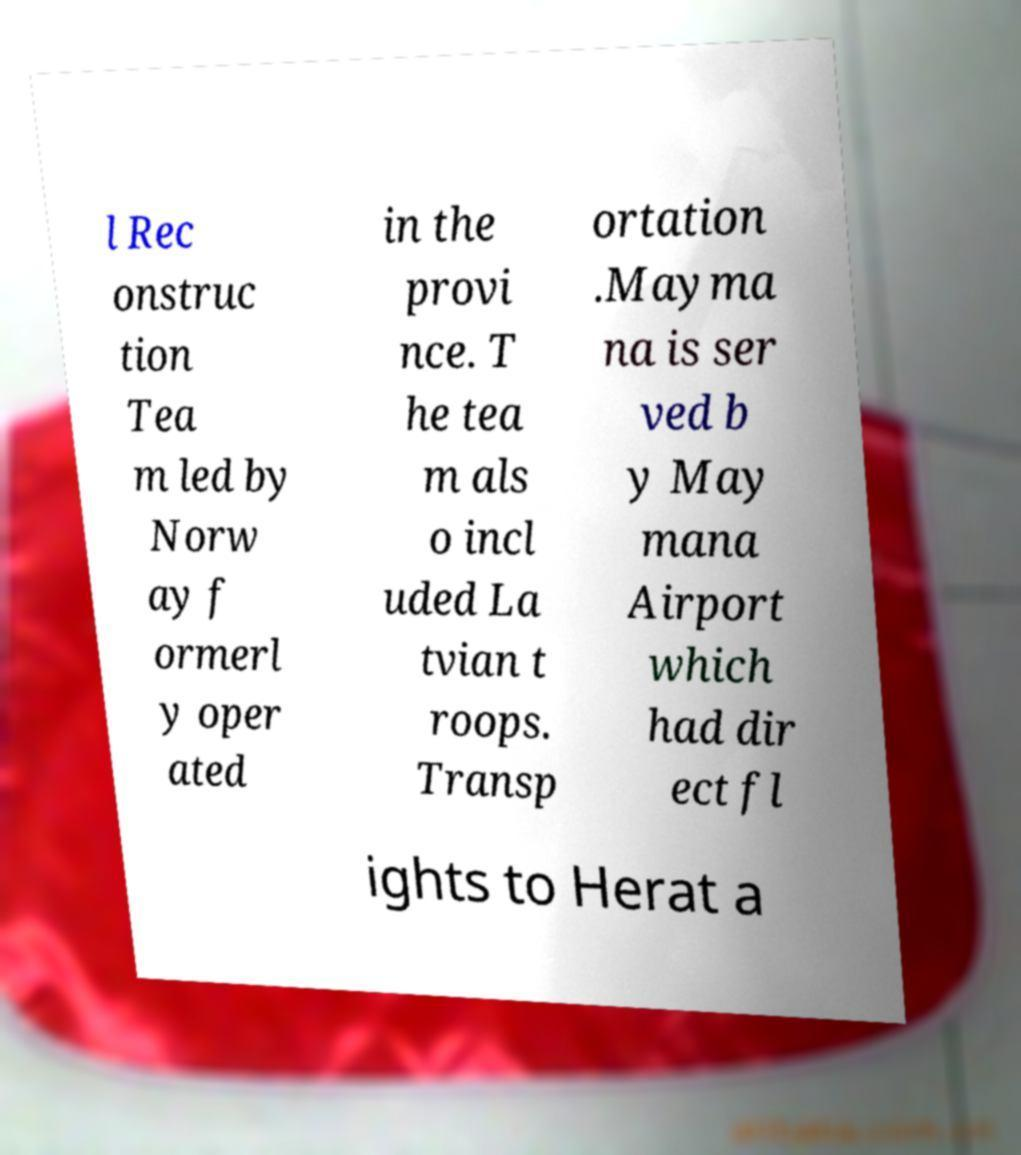Please identify and transcribe the text found in this image. l Rec onstruc tion Tea m led by Norw ay f ormerl y oper ated in the provi nce. T he tea m als o incl uded La tvian t roops. Transp ortation .Mayma na is ser ved b y May mana Airport which had dir ect fl ights to Herat a 